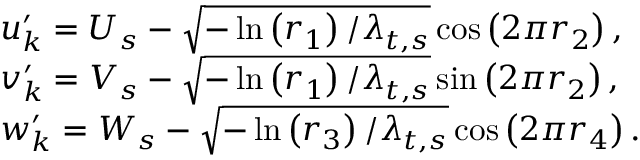<formula> <loc_0><loc_0><loc_500><loc_500>\begin{array} { r l } & { u _ { k } ^ { \prime } = U _ { s } - \sqrt { - \ln \left ( r _ { 1 } \right ) / \lambda _ { t , s } } \cos \left ( 2 \pi r _ { 2 } \right ) , } \\ & { v _ { k } ^ { \prime } = V _ { s } - \sqrt { - \ln \left ( r _ { 1 } \right ) / \lambda _ { t , s } } \sin \left ( 2 \pi r _ { 2 } \right ) , } \\ & { w _ { k } ^ { \prime } = W _ { s } - \sqrt { - \ln \left ( r _ { 3 } \right ) / \lambda _ { t , s } } \cos \left ( 2 \pi r _ { 4 } \right ) . } \end{array}</formula> 